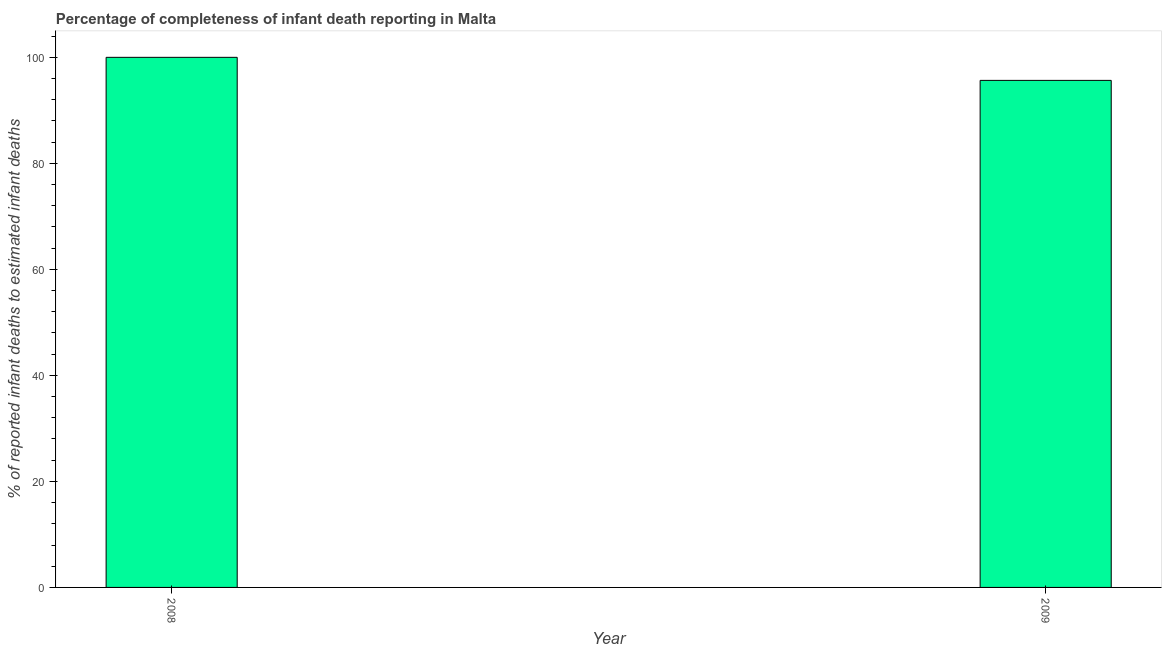Does the graph contain grids?
Offer a terse response. No. What is the title of the graph?
Make the answer very short. Percentage of completeness of infant death reporting in Malta. What is the label or title of the Y-axis?
Your answer should be compact. % of reported infant deaths to estimated infant deaths. What is the completeness of infant death reporting in 2009?
Provide a succinct answer. 95.65. Across all years, what is the maximum completeness of infant death reporting?
Your answer should be compact. 100. Across all years, what is the minimum completeness of infant death reporting?
Keep it short and to the point. 95.65. In which year was the completeness of infant death reporting minimum?
Make the answer very short. 2009. What is the sum of the completeness of infant death reporting?
Offer a terse response. 195.65. What is the difference between the completeness of infant death reporting in 2008 and 2009?
Provide a short and direct response. 4.35. What is the average completeness of infant death reporting per year?
Your answer should be compact. 97.83. What is the median completeness of infant death reporting?
Keep it short and to the point. 97.83. In how many years, is the completeness of infant death reporting greater than 32 %?
Your answer should be compact. 2. What is the ratio of the completeness of infant death reporting in 2008 to that in 2009?
Your response must be concise. 1.04. In how many years, is the completeness of infant death reporting greater than the average completeness of infant death reporting taken over all years?
Your answer should be compact. 1. Are all the bars in the graph horizontal?
Provide a succinct answer. No. What is the difference between two consecutive major ticks on the Y-axis?
Ensure brevity in your answer.  20. Are the values on the major ticks of Y-axis written in scientific E-notation?
Give a very brief answer. No. What is the % of reported infant deaths to estimated infant deaths in 2009?
Make the answer very short. 95.65. What is the difference between the % of reported infant deaths to estimated infant deaths in 2008 and 2009?
Offer a very short reply. 4.35. What is the ratio of the % of reported infant deaths to estimated infant deaths in 2008 to that in 2009?
Provide a short and direct response. 1.04. 